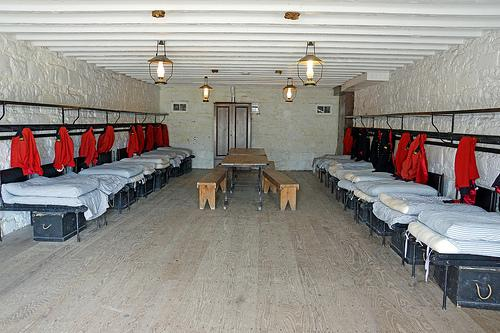Question: what surrounds the tables?
Choices:
A. Benches.
B. Food.
C. Chairs.
D. Balloons.
Answer with the letter. Answer: A Question: what color is the ceiling?
Choices:
A. Beige.
B. Brown.
C. Yellow.
D. White.
Answer with the letter. Answer: D Question: how many lights are visible?
Choices:
A. 5.
B. 6.
C. 4.
D. 7.
Answer with the letter. Answer: C Question: how many air vents are seen on the far wall?
Choices:
A. 3.
B. 4.
C. 2.
D. 5.
Answer with the letter. Answer: C Question: what lines the walls?
Choices:
A. Trash.
B. Cars.
C. Beds.
D. Toys.
Answer with the letter. Answer: C 